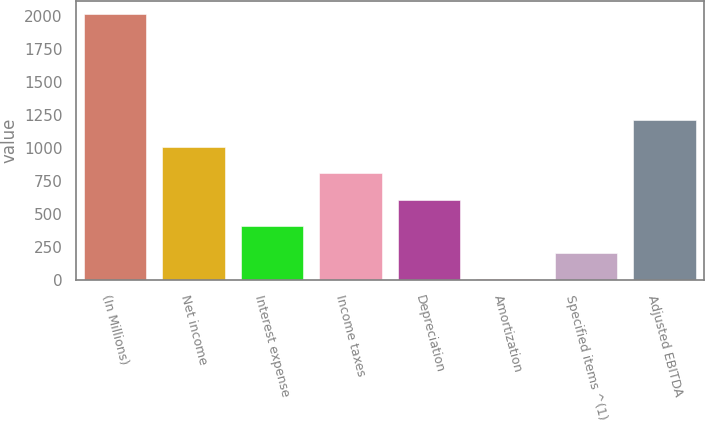Convert chart. <chart><loc_0><loc_0><loc_500><loc_500><bar_chart><fcel>(In Millions)<fcel>Net income<fcel>Interest expense<fcel>Income taxes<fcel>Depreciation<fcel>Amortization<fcel>Specified items ^(1)<fcel>Adjusted EBITDA<nl><fcel>2009<fcel>1007.6<fcel>406.76<fcel>807.32<fcel>607.04<fcel>6.2<fcel>206.48<fcel>1207.88<nl></chart> 